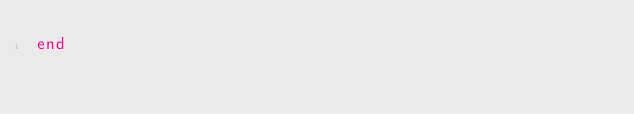<code> <loc_0><loc_0><loc_500><loc_500><_Ruby_>end
</code> 